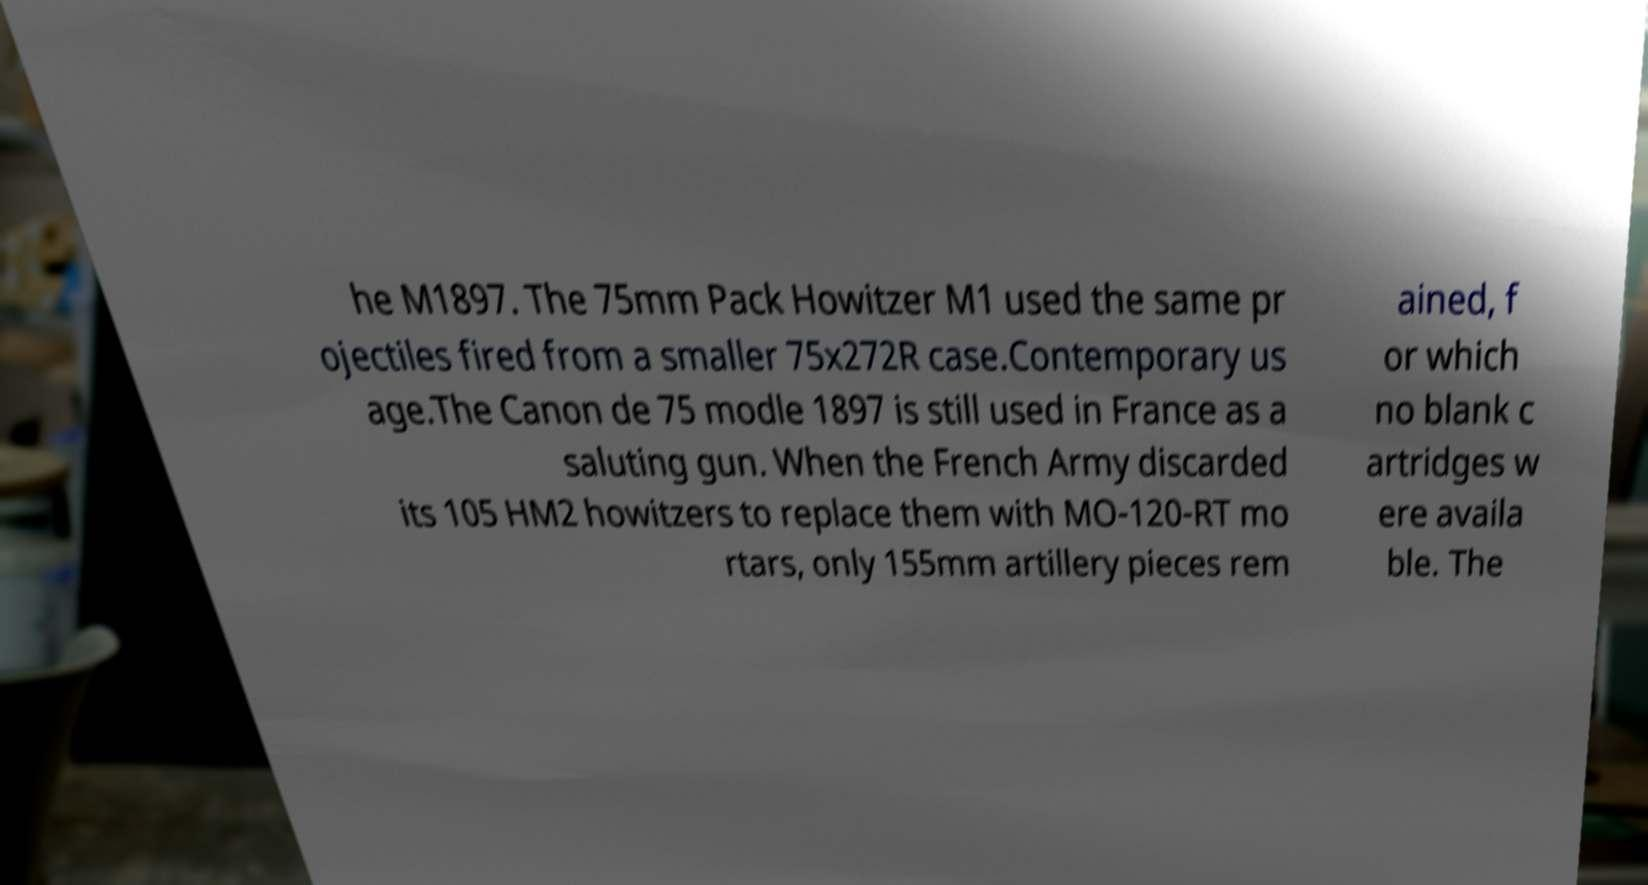Can you read and provide the text displayed in the image?This photo seems to have some interesting text. Can you extract and type it out for me? he M1897. The 75mm Pack Howitzer M1 used the same pr ojectiles fired from a smaller 75x272R case.Contemporary us age.The Canon de 75 modle 1897 is still used in France as a saluting gun. When the French Army discarded its 105 HM2 howitzers to replace them with MO-120-RT mo rtars, only 155mm artillery pieces rem ained, f or which no blank c artridges w ere availa ble. The 